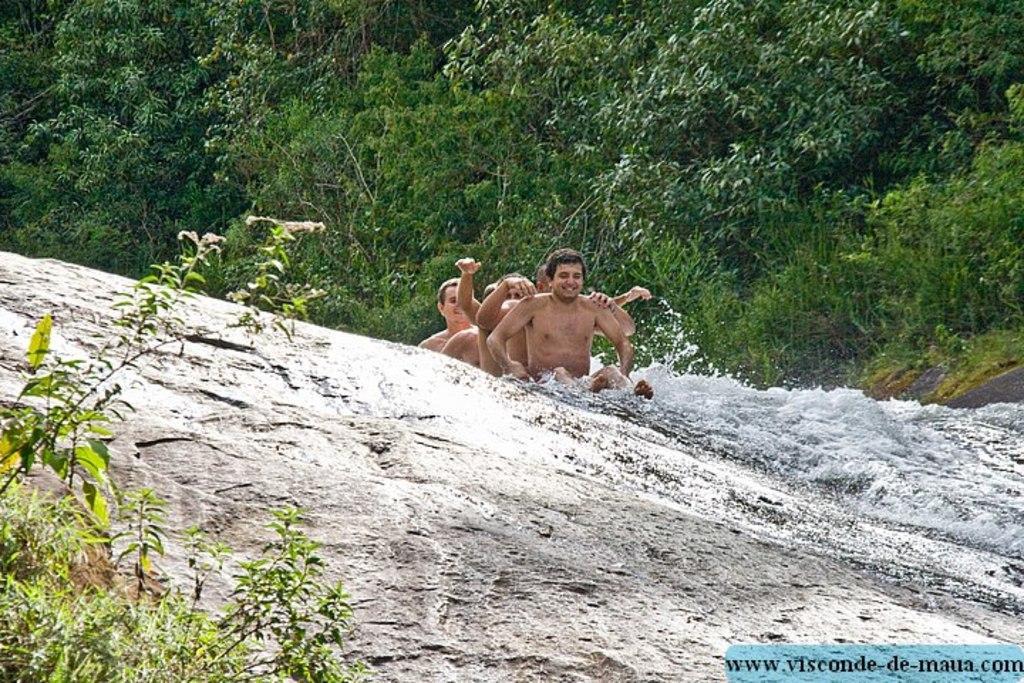Describe this image in one or two sentences. In this picture i see few men seated on the rock and i see water flowing and on the right side I see few trees and on the left I see few plants and i see text at the bottom right corner of the picture. 